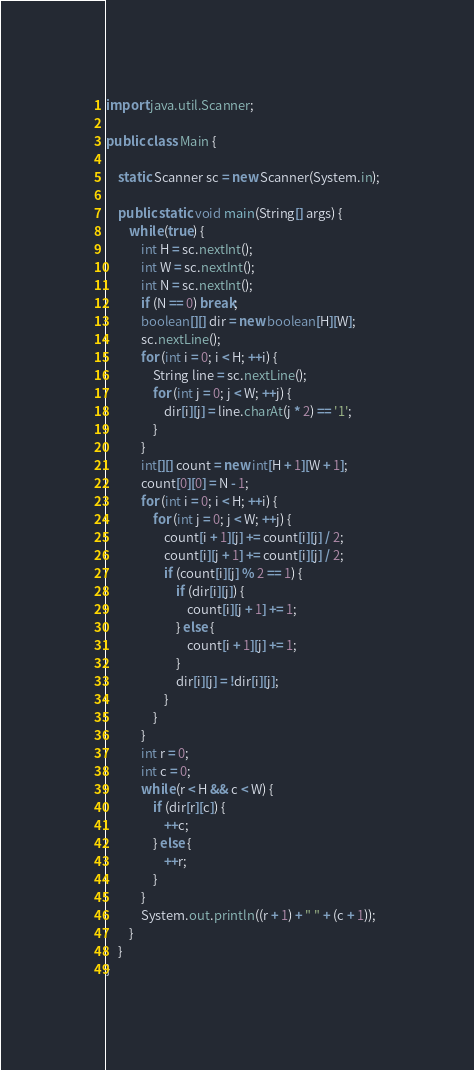Convert code to text. <code><loc_0><loc_0><loc_500><loc_500><_Java_>import java.util.Scanner;

public class Main {

	static Scanner sc = new Scanner(System.in);

	public static void main(String[] args) {
		while (true) {
			int H = sc.nextInt();
			int W = sc.nextInt();
			int N = sc.nextInt();
			if (N == 0) break;
			boolean[][] dir = new boolean[H][W];
			sc.nextLine();
			for (int i = 0; i < H; ++i) {
				String line = sc.nextLine();
				for (int j = 0; j < W; ++j) {
					dir[i][j] = line.charAt(j * 2) == '1';
				}
			}
			int[][] count = new int[H + 1][W + 1];
			count[0][0] = N - 1;
			for (int i = 0; i < H; ++i) {
				for (int j = 0; j < W; ++j) {
					count[i + 1][j] += count[i][j] / 2;
					count[i][j + 1] += count[i][j] / 2;
					if (count[i][j] % 2 == 1) {
						if (dir[i][j]) {
							count[i][j + 1] += 1;
						} else {
							count[i + 1][j] += 1;
						}
						dir[i][j] = !dir[i][j];
					}
				}
			}
			int r = 0;
			int c = 0;
			while (r < H && c < W) {
				if (dir[r][c]) {
					++c;
				} else {
					++r;
				}
			}
			System.out.println((r + 1) + " " + (c + 1));
		}
	}
}</code> 